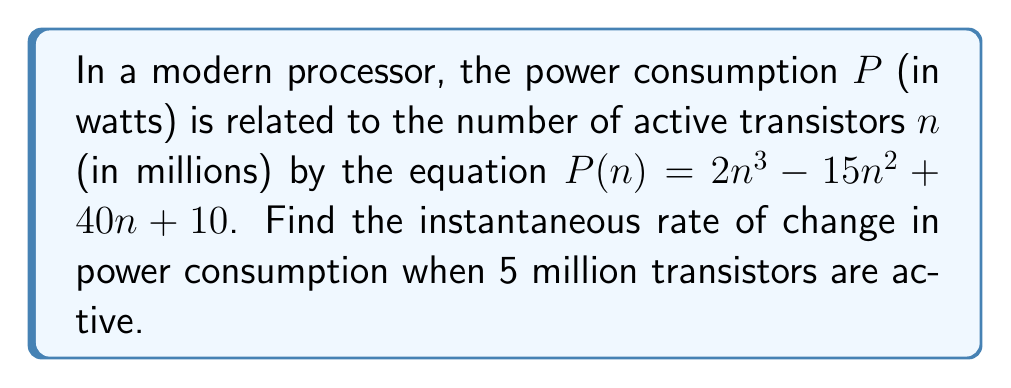Can you answer this question? To find the instantaneous rate of change, we need to calculate the derivative of the power consumption function $P(n)$ and evaluate it at $n = 5$.

Step 1: Find the derivative of $P(n)$
$$\frac{d}{dn}P(n) = \frac{d}{dn}(2n^3 - 15n^2 + 40n + 10)$$
$$P'(n) = 6n^2 - 30n + 40$$

Step 2: Evaluate $P'(n)$ at $n = 5$
$$P'(5) = 6(5)^2 - 30(5) + 40$$
$$P'(5) = 6(25) - 150 + 40$$
$$P'(5) = 150 - 150 + 40$$
$$P'(5) = 40$$

The instantaneous rate of change is 40 watts per million transistors when 5 million transistors are active.
Answer: 40 W/million transistors 